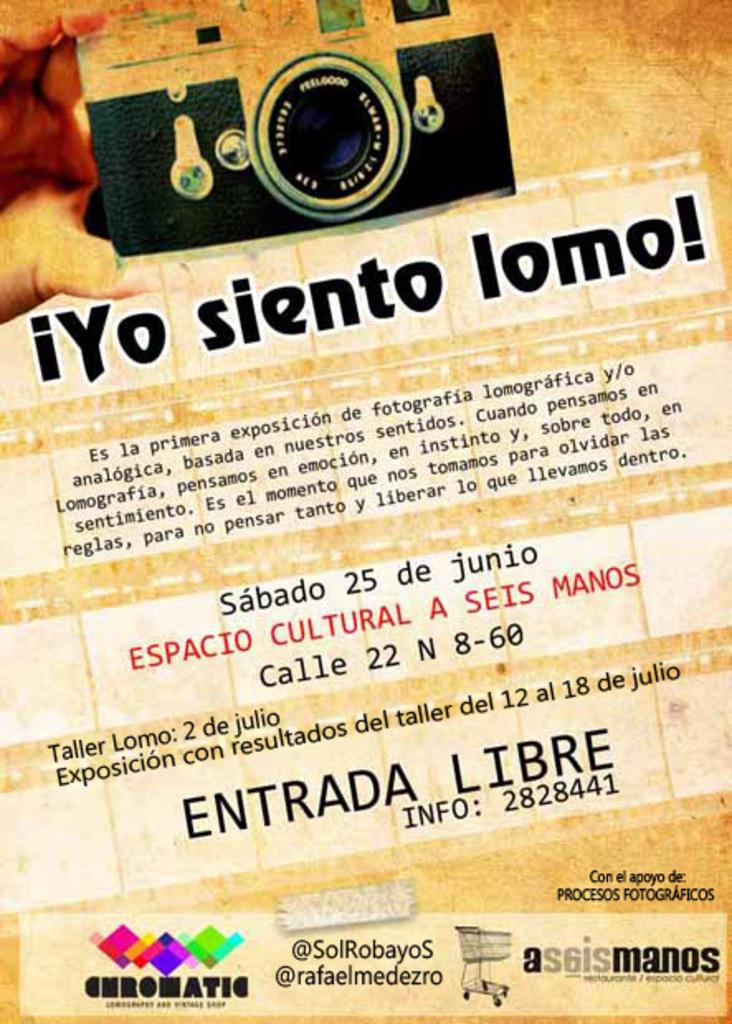What is present in the image that has text on it? There is a paper in the image that has text on it. Can you describe the text on the paper? Unfortunately, the specific content of the text cannot be determined from the image alone. What might the paper be used for? The paper could be used for various purposes, such as writing, printing, or drawing. Where is the lunchroom located in the image? There is no lunchroom present in the image. Can you describe the kiss between the two people in the image? There are no people or kisses depicted in the image; it only features a paper with text on it. 